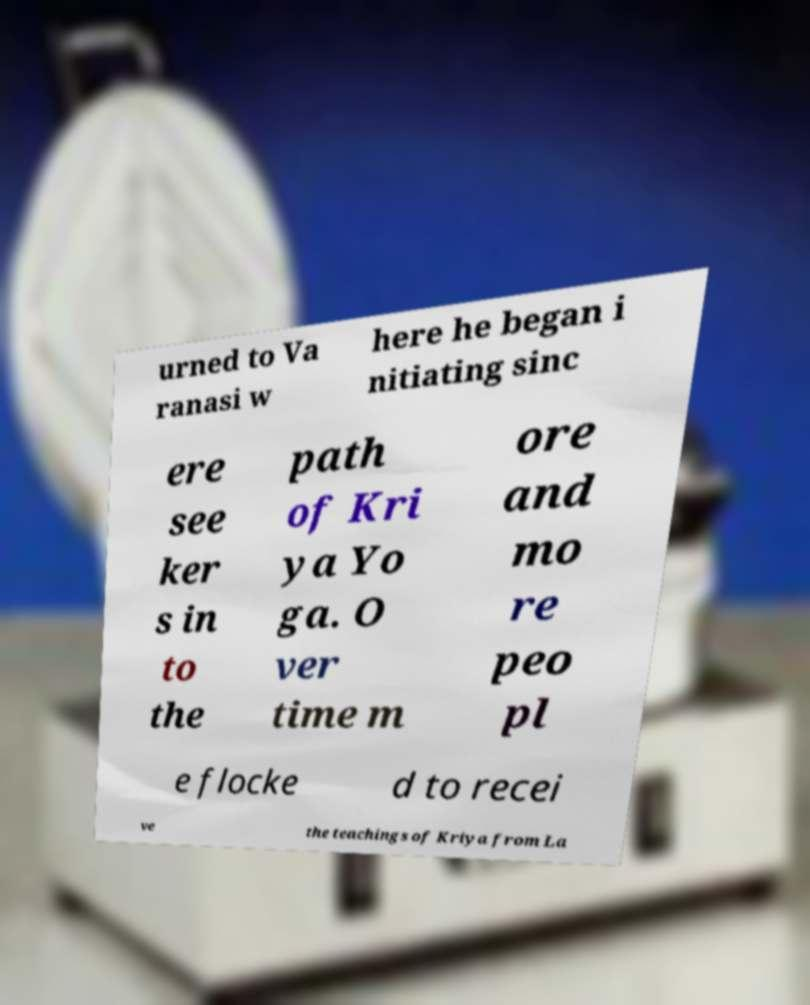For documentation purposes, I need the text within this image transcribed. Could you provide that? urned to Va ranasi w here he began i nitiating sinc ere see ker s in to the path of Kri ya Yo ga. O ver time m ore and mo re peo pl e flocke d to recei ve the teachings of Kriya from La 